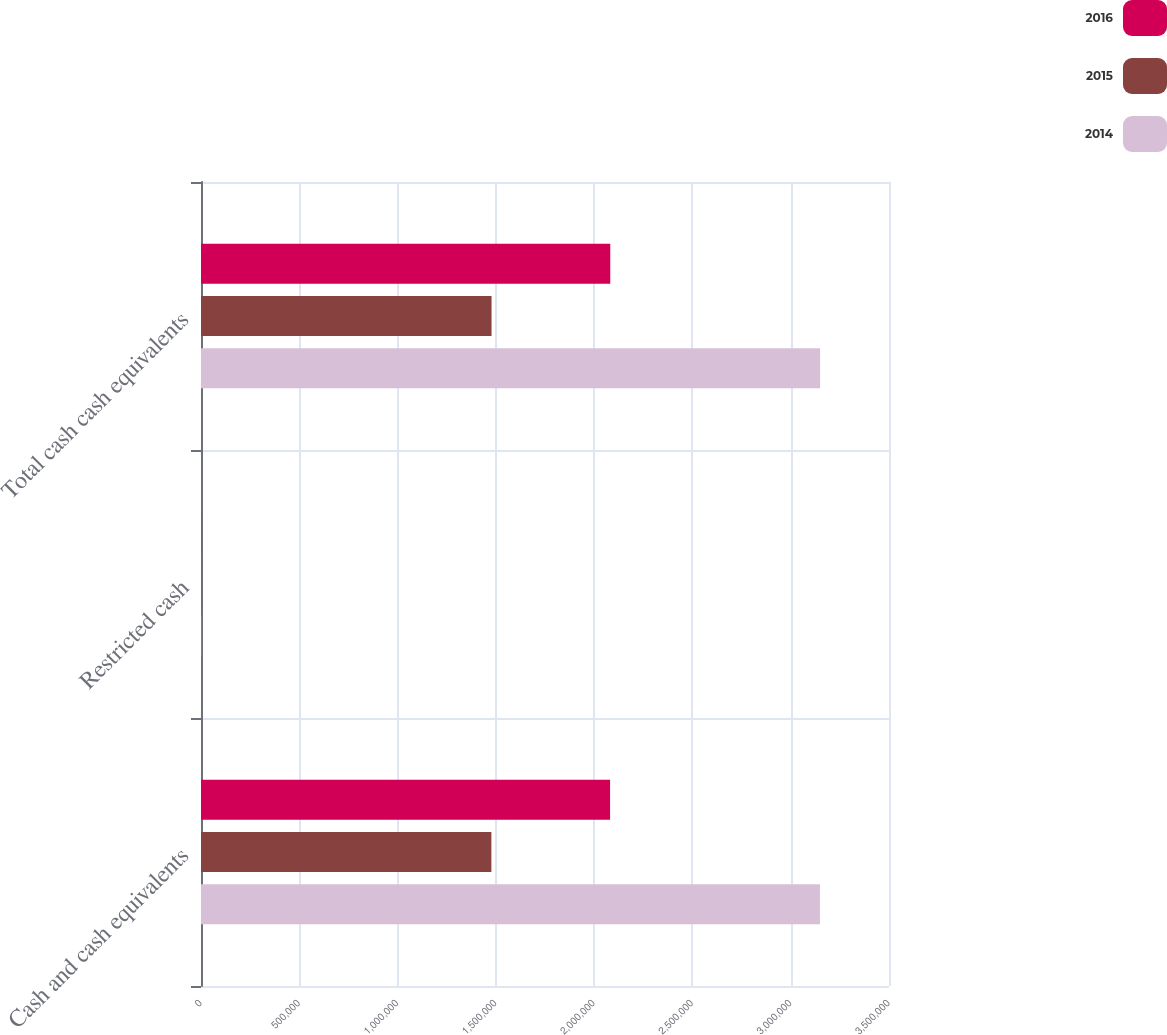Convert chart to OTSL. <chart><loc_0><loc_0><loc_500><loc_500><stacked_bar_chart><ecel><fcel>Cash and cash equivalents<fcel>Restricted cash<fcel>Total cash cash equivalents<nl><fcel>2016<fcel>2.08108e+06<fcel>932<fcel>2.08201e+06<nl><fcel>2015<fcel>1.47726e+06<fcel>806<fcel>1.47807e+06<nl><fcel>2014<fcel>3.14865e+06<fcel>843<fcel>3.14949e+06<nl></chart> 